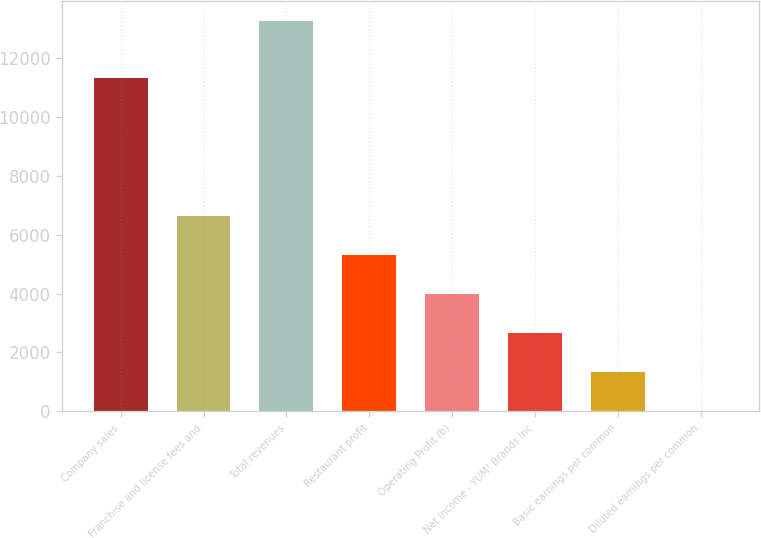Convert chart to OTSL. <chart><loc_0><loc_0><loc_500><loc_500><bar_chart><fcel>Company sales<fcel>Franchise and license fees and<fcel>Total revenues<fcel>Restaurant profit<fcel>Operating Profit (b)<fcel>Net Income - YUM! Brands Inc<fcel>Basic earnings per common<fcel>Diluted earnings per common<nl><fcel>11324<fcel>6640.67<fcel>13279<fcel>5313<fcel>3985.33<fcel>2657.66<fcel>1329.99<fcel>2.32<nl></chart> 